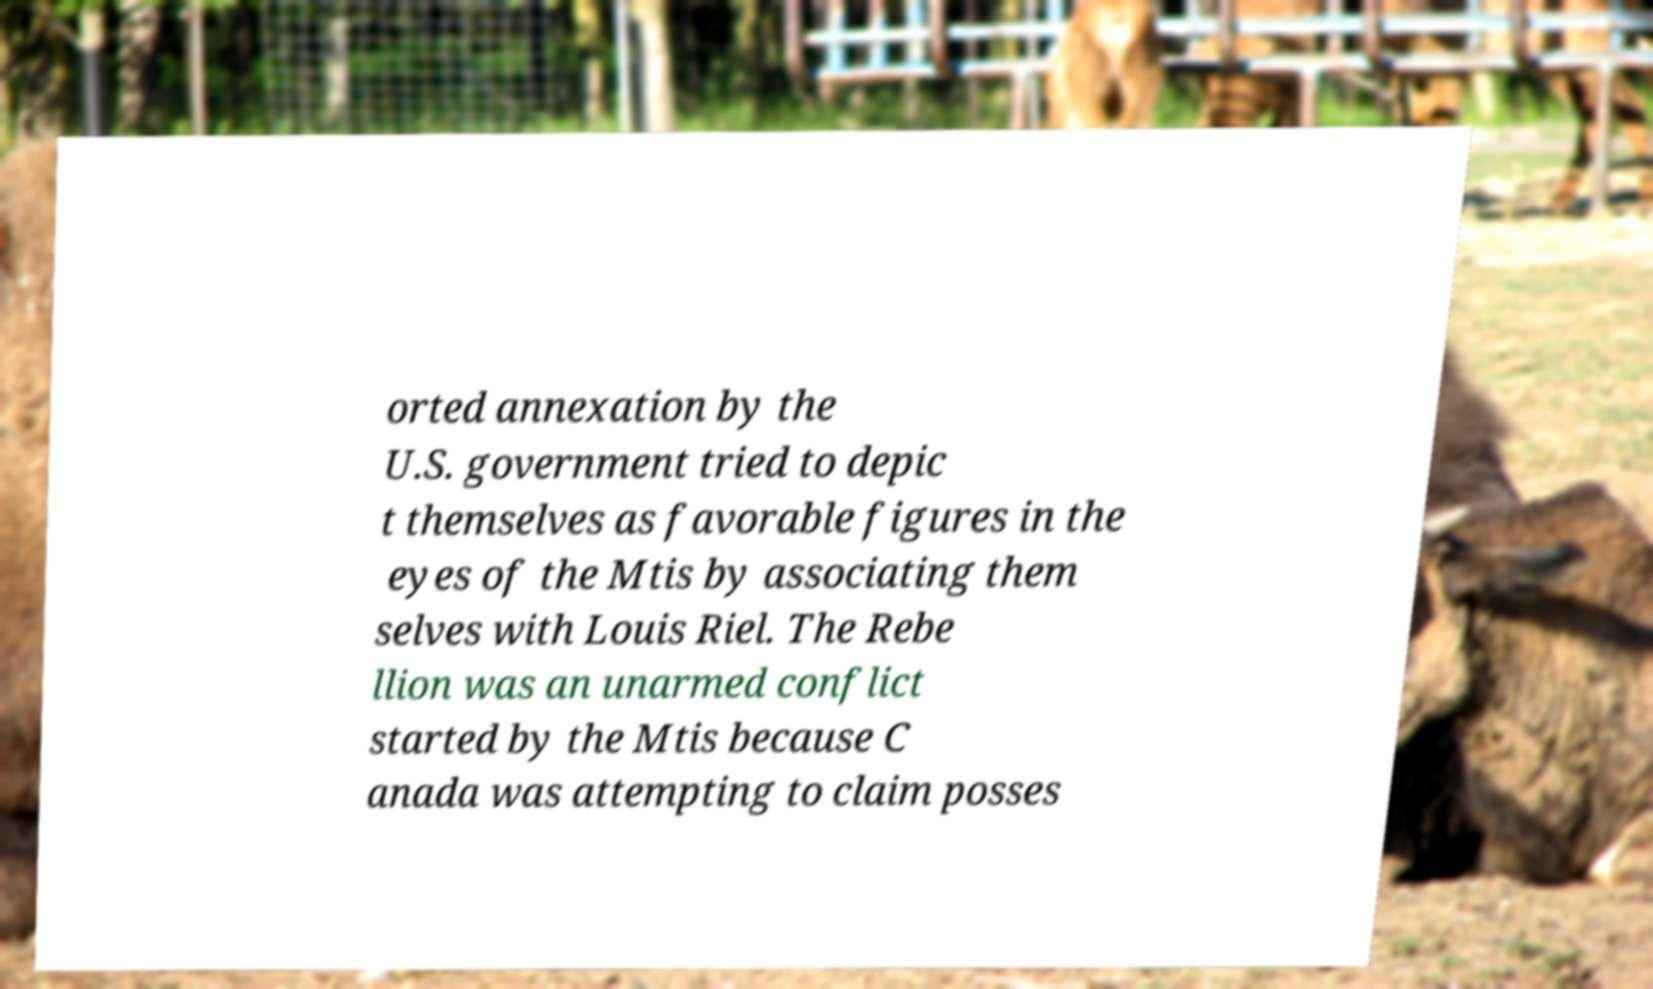Could you extract and type out the text from this image? orted annexation by the U.S. government tried to depic t themselves as favorable figures in the eyes of the Mtis by associating them selves with Louis Riel. The Rebe llion was an unarmed conflict started by the Mtis because C anada was attempting to claim posses 